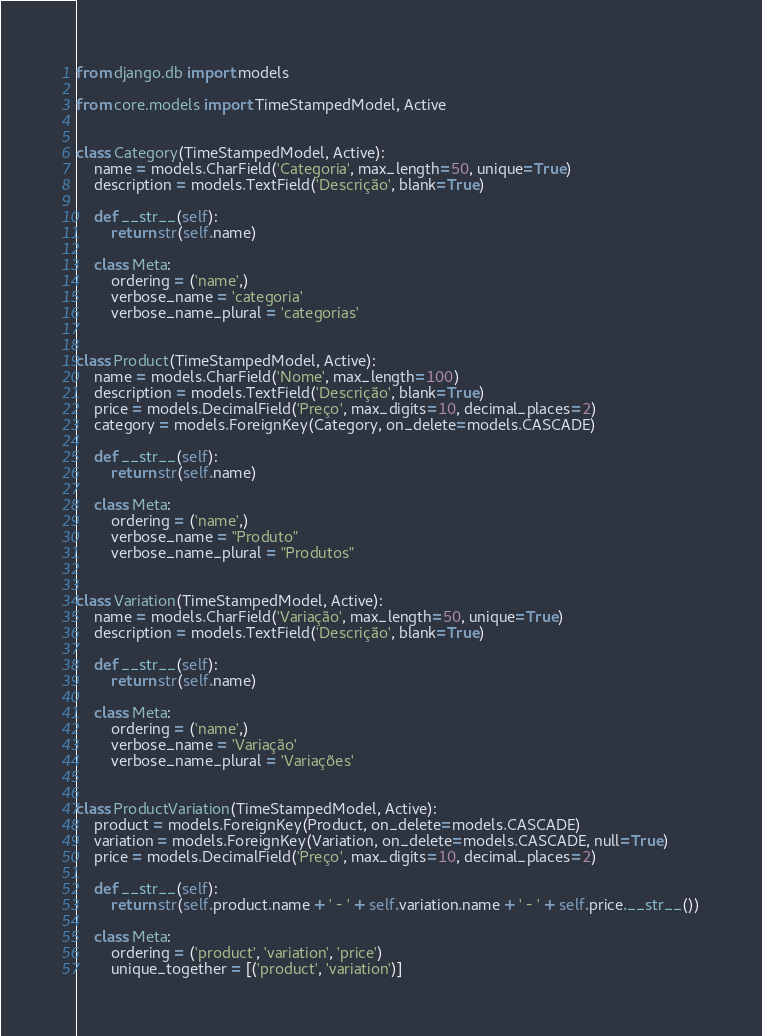<code> <loc_0><loc_0><loc_500><loc_500><_Python_>from django.db import models

from core.models import TimeStampedModel, Active


class Category(TimeStampedModel, Active):
    name = models.CharField('Categoria', max_length=50, unique=True)
    description = models.TextField('Descrição', blank=True)

    def __str__(self):
        return str(self.name)

    class Meta:
        ordering = ('name',)
        verbose_name = 'categoria'
        verbose_name_plural = 'categorias'


class Product(TimeStampedModel, Active):
    name = models.CharField('Nome', max_length=100)
    description = models.TextField('Descrição', blank=True)
    price = models.DecimalField('Preço', max_digits=10, decimal_places=2)
    category = models.ForeignKey(Category, on_delete=models.CASCADE)

    def __str__(self):
        return str(self.name)

    class Meta:
        ordering = ('name',)
        verbose_name = "Produto"
        verbose_name_plural = "Produtos"


class Variation(TimeStampedModel, Active):
    name = models.CharField('Variação', max_length=50, unique=True)
    description = models.TextField('Descrição', blank=True)

    def __str__(self):
        return str(self.name)

    class Meta:
        ordering = ('name',)
        verbose_name = 'Variação'
        verbose_name_plural = 'Variações'


class ProductVariation(TimeStampedModel, Active):
    product = models.ForeignKey(Product, on_delete=models.CASCADE)
    variation = models.ForeignKey(Variation, on_delete=models.CASCADE, null=True)
    price = models.DecimalField('Preço', max_digits=10, decimal_places=2)

    def __str__(self):
        return str(self.product.name + ' - ' + self.variation.name + ' - ' + self.price.__str__())

    class Meta:
        ordering = ('product', 'variation', 'price')
        unique_together = [('product', 'variation')]
</code> 